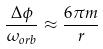Convert formula to latex. <formula><loc_0><loc_0><loc_500><loc_500>\frac { \Delta \phi } { \omega _ { o r b } } \approx \frac { 6 \pi m } { r }</formula> 